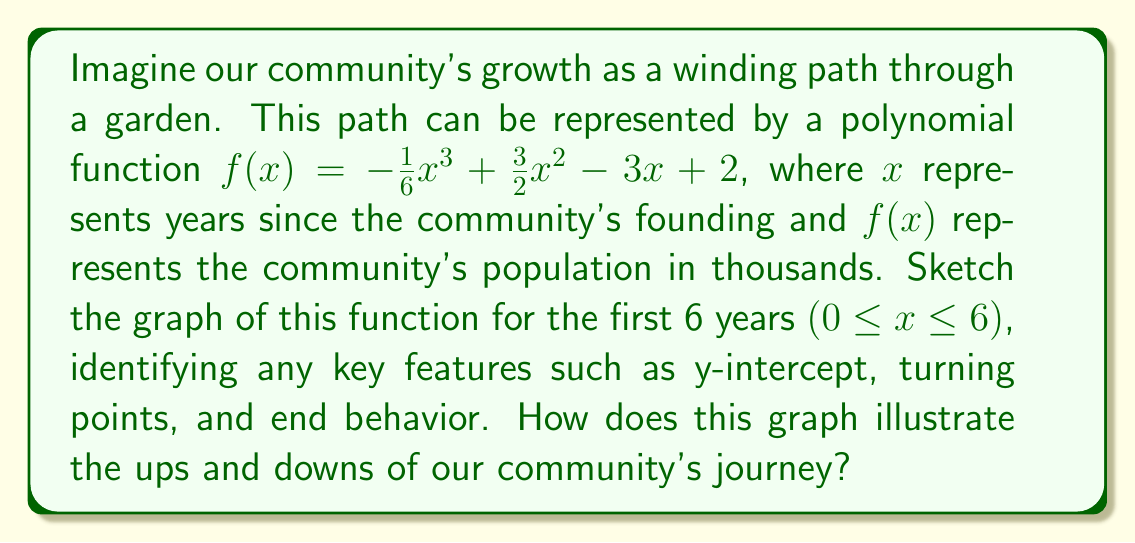What is the answer to this math problem? To sketch this polynomial graph, we'll follow these steps like planting seeds in our community garden:

1. Find the y-intercept:
   When $x = 0$, $f(0) = 2$. So the y-intercept is (0, 2).

2. Find the turning points (local maximum and minimum):
   $f'(x) = -\frac{1}{2}x^2 + 3x - 3$
   Set $f'(x) = 0$ and solve:
   $-\frac{1}{2}x^2 + 3x - 3 = 0$
   $(x - 1)(x - 2) = 0$
   $x = 1$ or $x = 2$

   Evaluate $f(1)$ and $f(2)$:
   $f(1) = -\frac{1}{6} + \frac{3}{2} - 3 + 2 = \frac{1}{3}$
   $f(2) = -\frac{4}{6} + 6 - 6 + 2 = \frac{4}{3}$

   So the turning points are $(1, \frac{1}{3})$ and $(2, \frac{4}{3})$

3. Find the end behavior:
   As $x \to -\infty$, $f(x) \to -\infty$
   As $x \to \infty$, $f(x) \to -\infty$

4. Sketch the graph:
   [asy]
   import graph;
   size(200,200);
   
   real f(real x) {return -1/6*x^3 + 3/2*x^2 - 3*x + 2;}
   
   xaxis("x", arrow=Arrow);
   yaxis("y", arrow=Arrow);
   
   draw(graph(f,0,6), blue);
   
   dot((0,2), red);
   dot((1,1/3), red);
   dot((2,4/3), red);
   
   label("(0,2)", (0,2), SW);
   label("(1,1/3)", (1,1/3), SE);
   label("(2,4/3)", (2,4/3), NW);
   [/asy]

This graph illustrates our community's growth journey:
- We start with 2,000 people (y-intercept).
- There's an initial decline as we face early challenges (to the first turning point).
- We then experience growth, reaching a peak of about 1,333 people after 2 years (second turning point).
- After this peak, we see a gradual decline, symbolizing new challenges or changes in the community.

The winding nature of the path represents the ups and downs of community development, much like the twists and turns of a garden path.
Answer: The sketch should show a cubic function starting at (0, 2), decreasing to a local minimum at $(1, \frac{1}{3})$, increasing to a local maximum at $(2, \frac{4}{3})$, and then decreasing again as x approaches 6. The graph illustrates the community's initial decline, followed by growth to a peak, and then a gradual decline, representing the changing phases of community development over the first 6 years. 